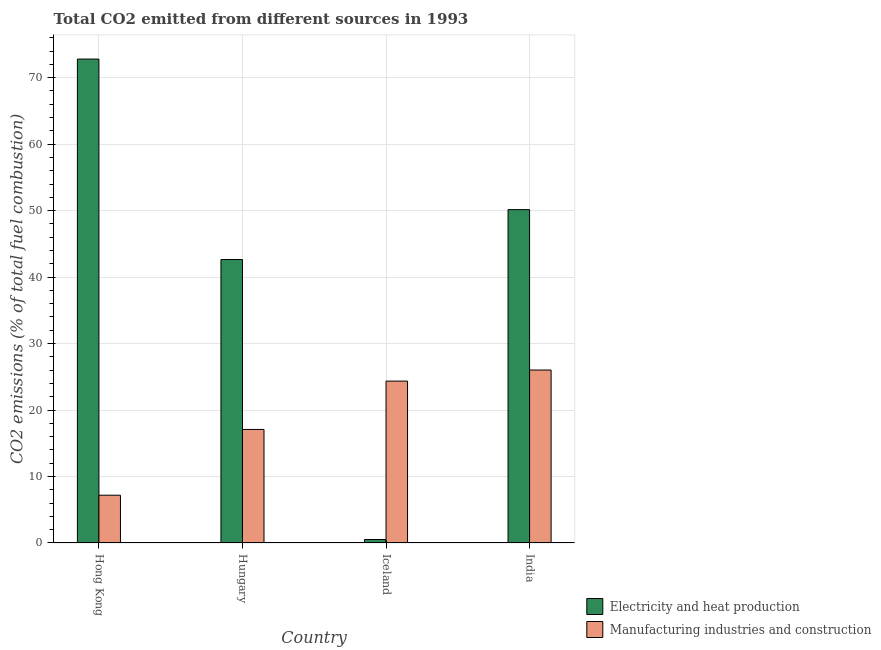How many different coloured bars are there?
Keep it short and to the point. 2. How many bars are there on the 1st tick from the right?
Offer a very short reply. 2. What is the label of the 1st group of bars from the left?
Your answer should be compact. Hong Kong. What is the co2 emissions due to electricity and heat production in Hong Kong?
Ensure brevity in your answer.  72.8. Across all countries, what is the maximum co2 emissions due to manufacturing industries?
Provide a succinct answer. 26.02. Across all countries, what is the minimum co2 emissions due to electricity and heat production?
Your response must be concise. 0.52. In which country was the co2 emissions due to manufacturing industries minimum?
Your answer should be very brief. Hong Kong. What is the total co2 emissions due to electricity and heat production in the graph?
Provide a short and direct response. 166.11. What is the difference between the co2 emissions due to manufacturing industries in Hong Kong and that in India?
Keep it short and to the point. -18.83. What is the difference between the co2 emissions due to electricity and heat production in Iceland and the co2 emissions due to manufacturing industries in Hong Kong?
Offer a terse response. -6.67. What is the average co2 emissions due to manufacturing industries per country?
Ensure brevity in your answer.  18.66. What is the difference between the co2 emissions due to manufacturing industries and co2 emissions due to electricity and heat production in Hong Kong?
Offer a terse response. -65.61. In how many countries, is the co2 emissions due to manufacturing industries greater than 66 %?
Offer a very short reply. 0. What is the ratio of the co2 emissions due to electricity and heat production in Hong Kong to that in India?
Your answer should be very brief. 1.45. Is the difference between the co2 emissions due to electricity and heat production in Hungary and India greater than the difference between the co2 emissions due to manufacturing industries in Hungary and India?
Provide a short and direct response. Yes. What is the difference between the highest and the second highest co2 emissions due to manufacturing industries?
Offer a very short reply. 1.67. What is the difference between the highest and the lowest co2 emissions due to manufacturing industries?
Offer a very short reply. 18.83. In how many countries, is the co2 emissions due to manufacturing industries greater than the average co2 emissions due to manufacturing industries taken over all countries?
Provide a succinct answer. 2. Is the sum of the co2 emissions due to electricity and heat production in Hungary and Iceland greater than the maximum co2 emissions due to manufacturing industries across all countries?
Offer a very short reply. Yes. What does the 1st bar from the left in Hungary represents?
Ensure brevity in your answer.  Electricity and heat production. What does the 1st bar from the right in Hong Kong represents?
Give a very brief answer. Manufacturing industries and construction. How many bars are there?
Provide a short and direct response. 8. Are all the bars in the graph horizontal?
Your answer should be very brief. No. How many countries are there in the graph?
Give a very brief answer. 4. Does the graph contain any zero values?
Your response must be concise. No. Does the graph contain grids?
Provide a succinct answer. Yes. Where does the legend appear in the graph?
Your response must be concise. Bottom right. How many legend labels are there?
Give a very brief answer. 2. How are the legend labels stacked?
Give a very brief answer. Vertical. What is the title of the graph?
Ensure brevity in your answer.  Total CO2 emitted from different sources in 1993. Does "Net National savings" appear as one of the legend labels in the graph?
Give a very brief answer. No. What is the label or title of the X-axis?
Provide a succinct answer. Country. What is the label or title of the Y-axis?
Provide a succinct answer. CO2 emissions (% of total fuel combustion). What is the CO2 emissions (% of total fuel combustion) in Electricity and heat production in Hong Kong?
Keep it short and to the point. 72.8. What is the CO2 emissions (% of total fuel combustion) in Manufacturing industries and construction in Hong Kong?
Make the answer very short. 7.19. What is the CO2 emissions (% of total fuel combustion) in Electricity and heat production in Hungary?
Offer a terse response. 42.64. What is the CO2 emissions (% of total fuel combustion) in Manufacturing industries and construction in Hungary?
Give a very brief answer. 17.08. What is the CO2 emissions (% of total fuel combustion) of Electricity and heat production in Iceland?
Offer a terse response. 0.52. What is the CO2 emissions (% of total fuel combustion) in Manufacturing industries and construction in Iceland?
Your answer should be compact. 24.35. What is the CO2 emissions (% of total fuel combustion) in Electricity and heat production in India?
Give a very brief answer. 50.15. What is the CO2 emissions (% of total fuel combustion) of Manufacturing industries and construction in India?
Offer a terse response. 26.02. Across all countries, what is the maximum CO2 emissions (% of total fuel combustion) of Electricity and heat production?
Your answer should be compact. 72.8. Across all countries, what is the maximum CO2 emissions (% of total fuel combustion) of Manufacturing industries and construction?
Provide a short and direct response. 26.02. Across all countries, what is the minimum CO2 emissions (% of total fuel combustion) in Electricity and heat production?
Ensure brevity in your answer.  0.52. Across all countries, what is the minimum CO2 emissions (% of total fuel combustion) in Manufacturing industries and construction?
Keep it short and to the point. 7.19. What is the total CO2 emissions (% of total fuel combustion) of Electricity and heat production in the graph?
Give a very brief answer. 166.11. What is the total CO2 emissions (% of total fuel combustion) of Manufacturing industries and construction in the graph?
Ensure brevity in your answer.  74.64. What is the difference between the CO2 emissions (% of total fuel combustion) of Electricity and heat production in Hong Kong and that in Hungary?
Ensure brevity in your answer.  30.16. What is the difference between the CO2 emissions (% of total fuel combustion) of Manufacturing industries and construction in Hong Kong and that in Hungary?
Your response must be concise. -9.89. What is the difference between the CO2 emissions (% of total fuel combustion) in Electricity and heat production in Hong Kong and that in Iceland?
Provide a succinct answer. 72.28. What is the difference between the CO2 emissions (% of total fuel combustion) of Manufacturing industries and construction in Hong Kong and that in Iceland?
Keep it short and to the point. -17.16. What is the difference between the CO2 emissions (% of total fuel combustion) of Electricity and heat production in Hong Kong and that in India?
Your answer should be very brief. 22.65. What is the difference between the CO2 emissions (% of total fuel combustion) in Manufacturing industries and construction in Hong Kong and that in India?
Give a very brief answer. -18.83. What is the difference between the CO2 emissions (% of total fuel combustion) of Electricity and heat production in Hungary and that in Iceland?
Make the answer very short. 42.12. What is the difference between the CO2 emissions (% of total fuel combustion) in Manufacturing industries and construction in Hungary and that in Iceland?
Your response must be concise. -7.27. What is the difference between the CO2 emissions (% of total fuel combustion) in Electricity and heat production in Hungary and that in India?
Provide a succinct answer. -7.5. What is the difference between the CO2 emissions (% of total fuel combustion) of Manufacturing industries and construction in Hungary and that in India?
Make the answer very short. -8.94. What is the difference between the CO2 emissions (% of total fuel combustion) in Electricity and heat production in Iceland and that in India?
Give a very brief answer. -49.63. What is the difference between the CO2 emissions (% of total fuel combustion) of Manufacturing industries and construction in Iceland and that in India?
Provide a short and direct response. -1.67. What is the difference between the CO2 emissions (% of total fuel combustion) in Electricity and heat production in Hong Kong and the CO2 emissions (% of total fuel combustion) in Manufacturing industries and construction in Hungary?
Offer a very short reply. 55.72. What is the difference between the CO2 emissions (% of total fuel combustion) in Electricity and heat production in Hong Kong and the CO2 emissions (% of total fuel combustion) in Manufacturing industries and construction in Iceland?
Provide a succinct answer. 48.45. What is the difference between the CO2 emissions (% of total fuel combustion) of Electricity and heat production in Hong Kong and the CO2 emissions (% of total fuel combustion) of Manufacturing industries and construction in India?
Your answer should be compact. 46.78. What is the difference between the CO2 emissions (% of total fuel combustion) of Electricity and heat production in Hungary and the CO2 emissions (% of total fuel combustion) of Manufacturing industries and construction in Iceland?
Keep it short and to the point. 18.29. What is the difference between the CO2 emissions (% of total fuel combustion) of Electricity and heat production in Hungary and the CO2 emissions (% of total fuel combustion) of Manufacturing industries and construction in India?
Offer a very short reply. 16.62. What is the difference between the CO2 emissions (% of total fuel combustion) in Electricity and heat production in Iceland and the CO2 emissions (% of total fuel combustion) in Manufacturing industries and construction in India?
Keep it short and to the point. -25.5. What is the average CO2 emissions (% of total fuel combustion) in Electricity and heat production per country?
Ensure brevity in your answer.  41.53. What is the average CO2 emissions (% of total fuel combustion) in Manufacturing industries and construction per country?
Your answer should be compact. 18.66. What is the difference between the CO2 emissions (% of total fuel combustion) of Electricity and heat production and CO2 emissions (% of total fuel combustion) of Manufacturing industries and construction in Hong Kong?
Provide a short and direct response. 65.61. What is the difference between the CO2 emissions (% of total fuel combustion) of Electricity and heat production and CO2 emissions (% of total fuel combustion) of Manufacturing industries and construction in Hungary?
Ensure brevity in your answer.  25.56. What is the difference between the CO2 emissions (% of total fuel combustion) in Electricity and heat production and CO2 emissions (% of total fuel combustion) in Manufacturing industries and construction in Iceland?
Provide a succinct answer. -23.83. What is the difference between the CO2 emissions (% of total fuel combustion) in Electricity and heat production and CO2 emissions (% of total fuel combustion) in Manufacturing industries and construction in India?
Your answer should be very brief. 24.13. What is the ratio of the CO2 emissions (% of total fuel combustion) in Electricity and heat production in Hong Kong to that in Hungary?
Keep it short and to the point. 1.71. What is the ratio of the CO2 emissions (% of total fuel combustion) of Manufacturing industries and construction in Hong Kong to that in Hungary?
Your response must be concise. 0.42. What is the ratio of the CO2 emissions (% of total fuel combustion) in Electricity and heat production in Hong Kong to that in Iceland?
Provide a succinct answer. 140.5. What is the ratio of the CO2 emissions (% of total fuel combustion) of Manufacturing industries and construction in Hong Kong to that in Iceland?
Your answer should be very brief. 0.3. What is the ratio of the CO2 emissions (% of total fuel combustion) in Electricity and heat production in Hong Kong to that in India?
Offer a very short reply. 1.45. What is the ratio of the CO2 emissions (% of total fuel combustion) of Manufacturing industries and construction in Hong Kong to that in India?
Your answer should be very brief. 0.28. What is the ratio of the CO2 emissions (% of total fuel combustion) of Electricity and heat production in Hungary to that in Iceland?
Your answer should be very brief. 82.3. What is the ratio of the CO2 emissions (% of total fuel combustion) in Manufacturing industries and construction in Hungary to that in Iceland?
Give a very brief answer. 0.7. What is the ratio of the CO2 emissions (% of total fuel combustion) of Electricity and heat production in Hungary to that in India?
Give a very brief answer. 0.85. What is the ratio of the CO2 emissions (% of total fuel combustion) of Manufacturing industries and construction in Hungary to that in India?
Your answer should be very brief. 0.66. What is the ratio of the CO2 emissions (% of total fuel combustion) of Electricity and heat production in Iceland to that in India?
Offer a terse response. 0.01. What is the ratio of the CO2 emissions (% of total fuel combustion) in Manufacturing industries and construction in Iceland to that in India?
Give a very brief answer. 0.94. What is the difference between the highest and the second highest CO2 emissions (% of total fuel combustion) of Electricity and heat production?
Your answer should be compact. 22.65. What is the difference between the highest and the second highest CO2 emissions (% of total fuel combustion) of Manufacturing industries and construction?
Your response must be concise. 1.67. What is the difference between the highest and the lowest CO2 emissions (% of total fuel combustion) in Electricity and heat production?
Provide a short and direct response. 72.28. What is the difference between the highest and the lowest CO2 emissions (% of total fuel combustion) of Manufacturing industries and construction?
Provide a short and direct response. 18.83. 